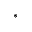<formula> <loc_0><loc_0><loc_500><loc_500>^ { \ast }</formula> 